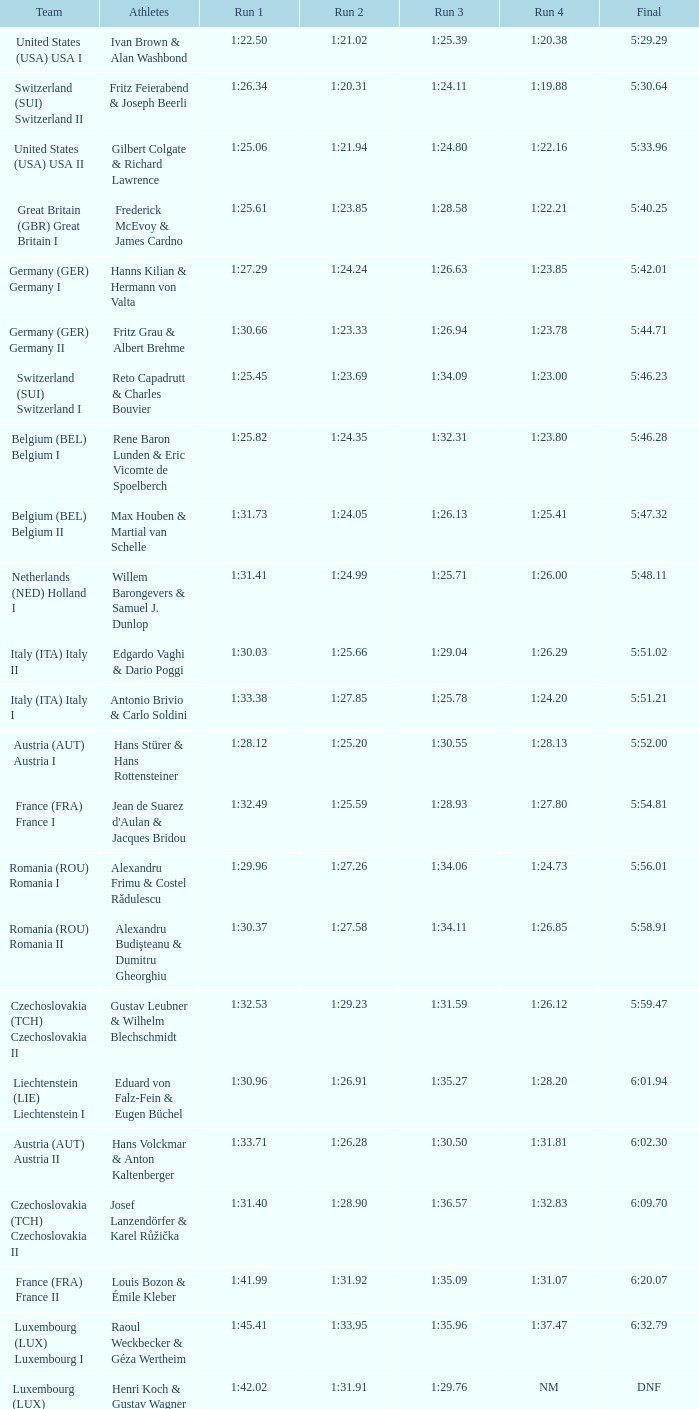In which final event is there a run 2 with a duration of 1:2 5:58.91. 